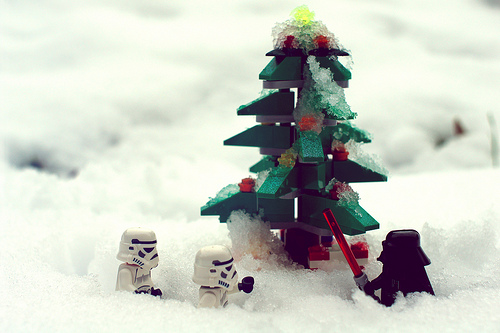<image>
Is the lego next to the darth vader? Yes. The lego is positioned adjacent to the darth vader, located nearby in the same general area. 